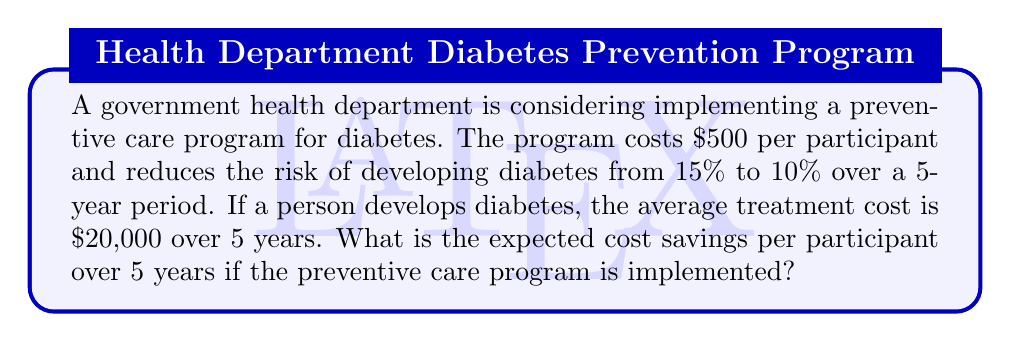Teach me how to tackle this problem. To solve this problem, we'll use decision analysis to compare the expected costs with and without the preventive care program.

1. Without the preventive care program:
   - Probability of developing diabetes: 15% = 0.15
   - Probability of not developing diabetes: 85% = 0.85
   - Expected cost:
     $$E(\text{cost}_{\text{without}}) = 0.15 \times \$20,000 + 0.85 \times \$0 = \$3,000$$

2. With the preventive care program:
   - Program cost: $500
   - Probability of developing diabetes: 10% = 0.10
   - Probability of not developing diabetes: 90% = 0.90
   - Expected cost:
     $$E(\text{cost}_{\text{with}}) = \$500 + 0.10 \times \$20,000 + 0.90 \times \$0 = \$2,500$$

3. Calculate the cost savings:
   $$\text{Cost savings} = E(\text{cost}_{\text{without}}) - E(\text{cost}_{\text{with}})$$
   $$\text{Cost savings} = \$3,000 - \$2,500 = \$500$$

Therefore, the expected cost savings per participant over 5 years is $500.
Answer: $500 